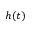<formula> <loc_0><loc_0><loc_500><loc_500>h ( t )</formula> 